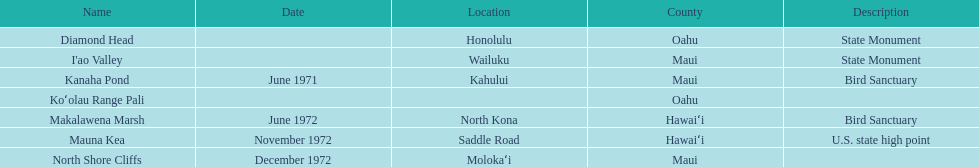How many images are listed? 6. 